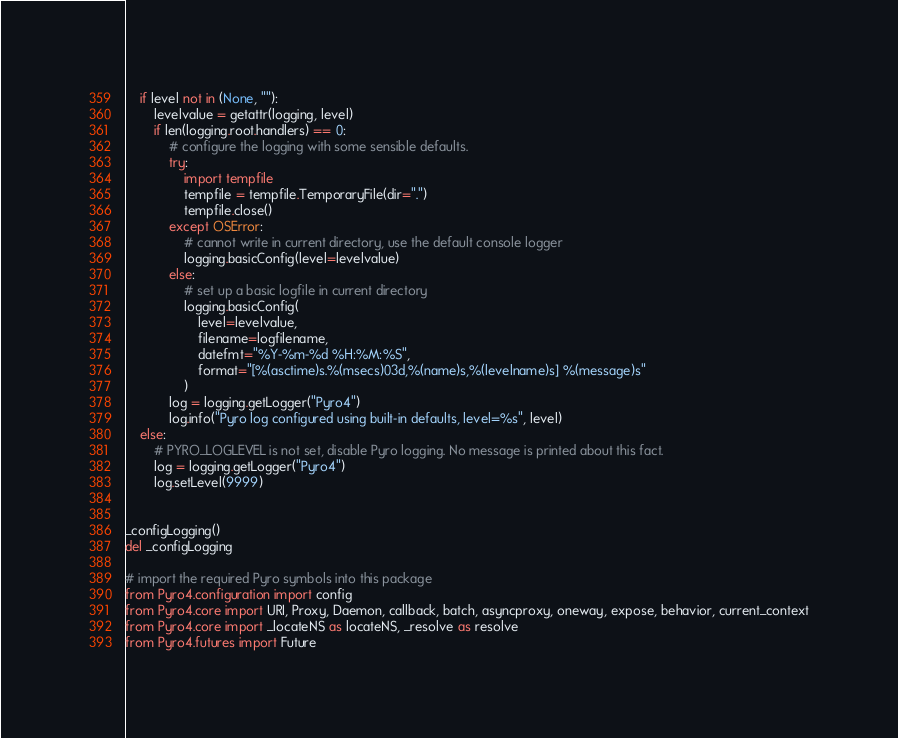<code> <loc_0><loc_0><loc_500><loc_500><_Python_>    if level not in (None, ""):
        levelvalue = getattr(logging, level)
        if len(logging.root.handlers) == 0:
            # configure the logging with some sensible defaults.
            try:
                import tempfile
                tempfile = tempfile.TemporaryFile(dir=".")
                tempfile.close()
            except OSError:
                # cannot write in current directory, use the default console logger
                logging.basicConfig(level=levelvalue)
            else:
                # set up a basic logfile in current directory
                logging.basicConfig(
                    level=levelvalue,
                    filename=logfilename,
                    datefmt="%Y-%m-%d %H:%M:%S",
                    format="[%(asctime)s.%(msecs)03d,%(name)s,%(levelname)s] %(message)s"
                )
            log = logging.getLogger("Pyro4")
            log.info("Pyro log configured using built-in defaults, level=%s", level)
    else:
        # PYRO_LOGLEVEL is not set, disable Pyro logging. No message is printed about this fact.
        log = logging.getLogger("Pyro4")
        log.setLevel(9999)


_configLogging()
del _configLogging

# import the required Pyro symbols into this package
from Pyro4.configuration import config
from Pyro4.core import URI, Proxy, Daemon, callback, batch, asyncproxy, oneway, expose, behavior, current_context
from Pyro4.core import _locateNS as locateNS, _resolve as resolve
from Pyro4.futures import Future
</code> 